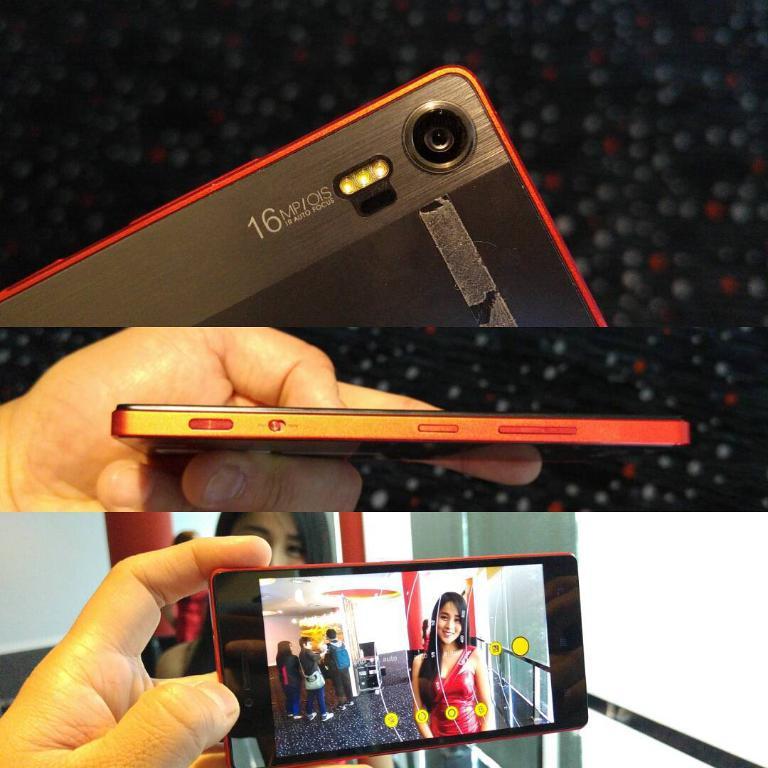What number is written on the back of the phone near the camera?
Provide a succinct answer. 16. Does the camera autofocus?
Give a very brief answer. Unanswerable. 